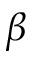<formula> <loc_0><loc_0><loc_500><loc_500>\beta</formula> 